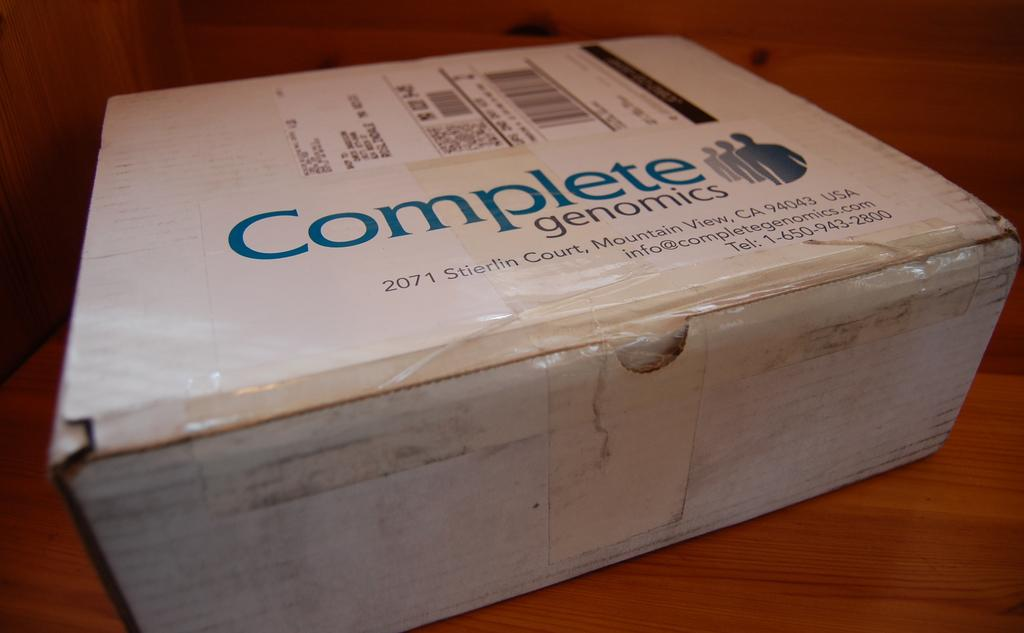<image>
Offer a succinct explanation of the picture presented. A BOX WITH A PREPAID LABEL ON IT NEXT TO A LABEL THAT SAYS 'COMPLETE genomics". 